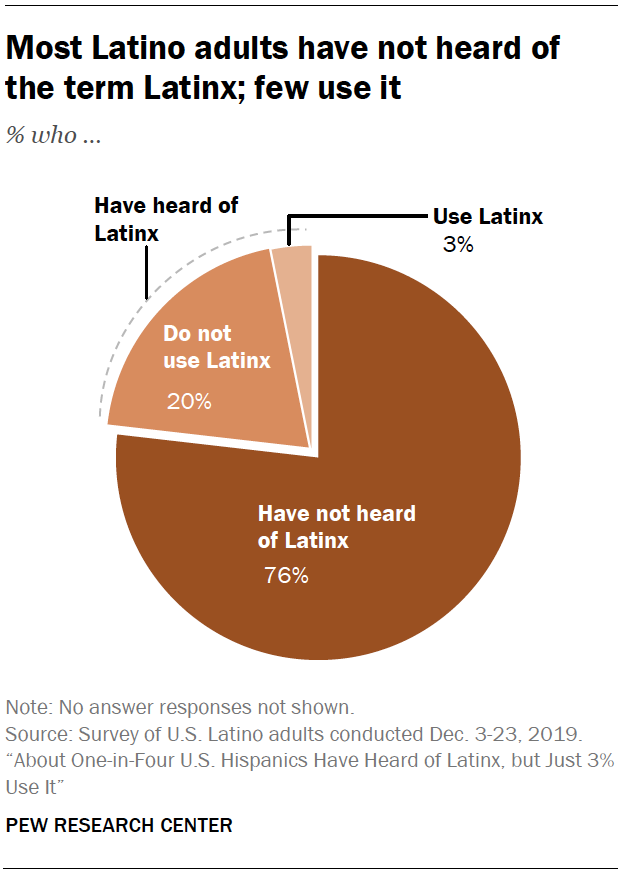Outline some significant characteristics in this image. Se representa el 76 por ciento en un gráfico de Pie? No han oído hablar de Latinx. The sum of 'Use Latinx' and 'Have heard of Latinx' is 23. 